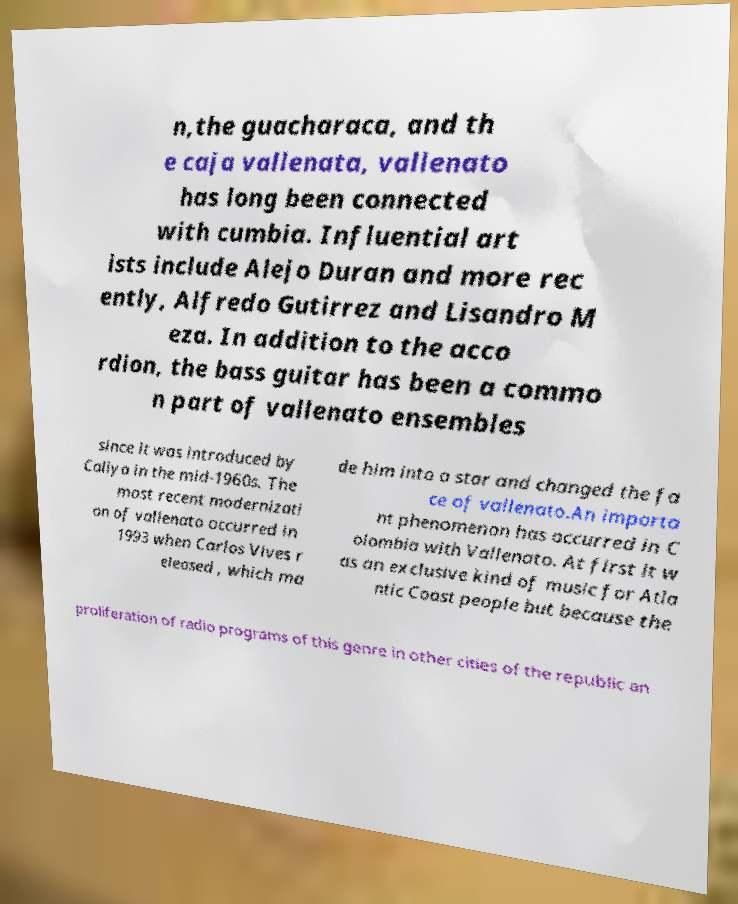I need the written content from this picture converted into text. Can you do that? n,the guacharaca, and th e caja vallenata, vallenato has long been connected with cumbia. Influential art ists include Alejo Duran and more rec ently, Alfredo Gutirrez and Lisandro M eza. In addition to the acco rdion, the bass guitar has been a commo n part of vallenato ensembles since it was introduced by Caliya in the mid-1960s. The most recent modernizati on of vallenato occurred in 1993 when Carlos Vives r eleased , which ma de him into a star and changed the fa ce of vallenato.An importa nt phenomenon has occurred in C olombia with Vallenato. At first it w as an exclusive kind of music for Atla ntic Coast people but because the proliferation of radio programs of this genre in other cities of the republic an 